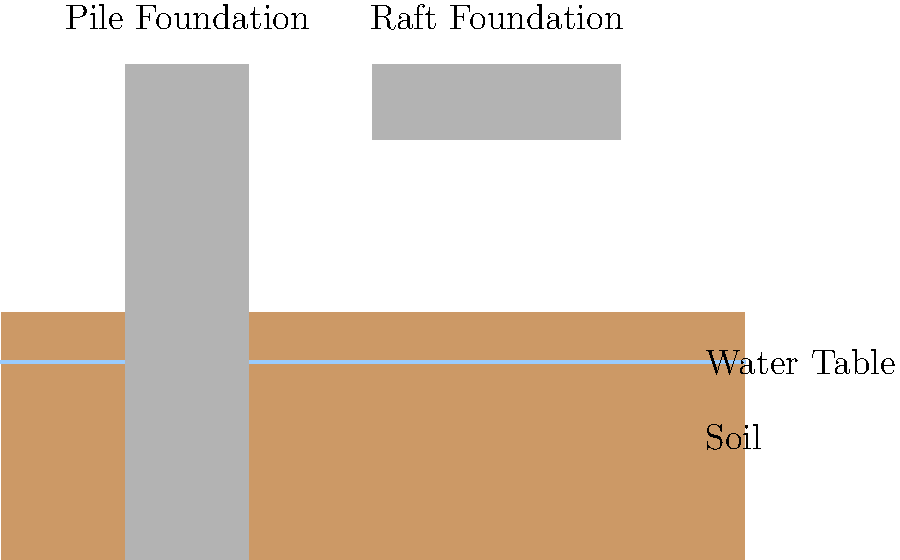Consider the cross-sectional diagram showing two types of building foundations: a pile foundation and a raft foundation. Given that the water table is at a depth of 2 meters and the soil has a bearing capacity of 150 kN/m², which foundation type would be more suitable for a 15-story office building in an area prone to soil settlement? Explain your reasoning considering the economic implications and long-term sustainability of the structure. To answer this question, we need to consider several factors:

1. Soil Conditions:
   - The water table is relatively high (2 meters deep), which can lead to soil instability.
   - The soil bearing capacity of 150 kN/m² is moderate, indicating potentially challenging ground conditions.

2. Building Characteristics:
   - A 15-story office building is a heavy structure that will exert significant loads on the foundation.

3. Pile Foundation:
   - Advantages:
     a) Transfers loads to deeper, more stable soil layers.
     b) Minimizes the impact of soil settlement.
     c) Suitable for weak or water-logged soils.
   - Disadvantages:
     a) Higher initial construction costs.
     b) More complex installation process.

4. Raft Foundation:
   - Advantages:
     a) Distributes the load over a larger area.
     b) Generally less expensive than pile foundations.
     c) Faster to construct.
   - Disadvantages:
     a) More susceptible to differential settlement in unstable soils.
     b) May not be suitable for very heavy structures in poor soil conditions.

5. Economic Implications:
   - While pile foundations have higher initial costs, they often result in lower long-term maintenance costs and reduced risk of structural damage due to settlement.
   - Raft foundations may seem more economical initially but could lead to higher costs over time if settlement issues occur.

6. Long-term Sustainability:
   - Pile foundations typically provide better long-term stability, especially in areas prone to soil settlement.
   - This increased stability can lead to a longer lifespan for the building, which is more sustainable from both an economic and environmental perspective.

Given the high water table, moderate soil bearing capacity, and the fact that the area is prone to soil settlement, the pile foundation would be more suitable for the 15-story office building. While it may have higher upfront costs, it offers better long-term stability and sustainability, which aligns with the economic principle of considering long-term benefits over short-term savings.
Answer: Pile foundation, due to better long-term stability and sustainability in challenging soil conditions, despite higher initial costs. 